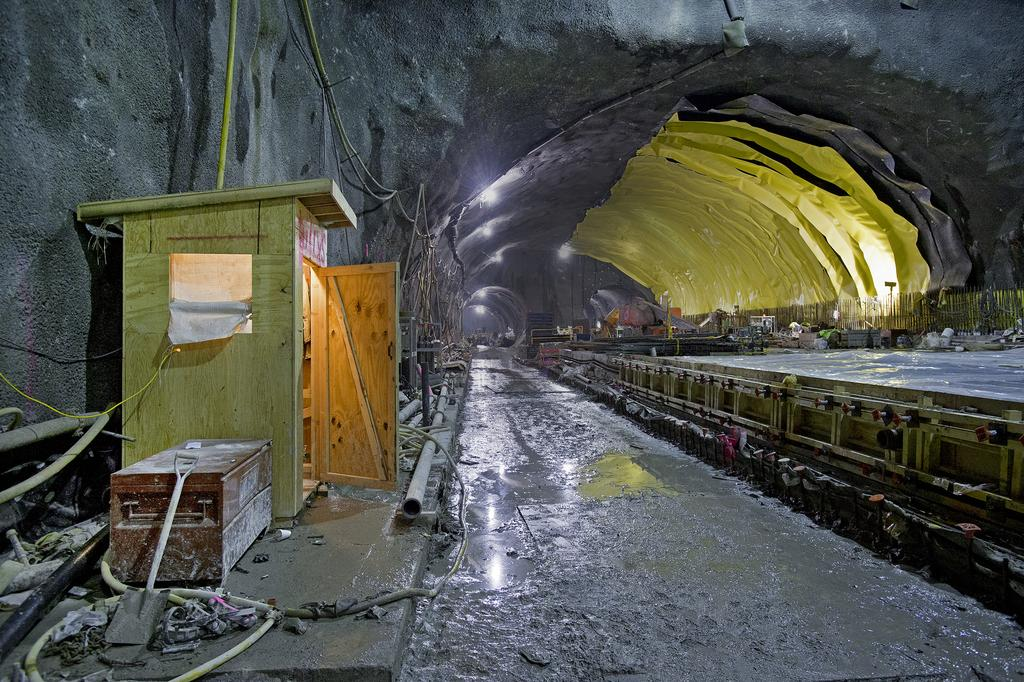What is the main feature of the image? There is a tunnel in the image. What objects can be seen inside the tunnel? A shovel, pipes, a box, cables, and lights are visible in the tunnel. Are there any people present in the image? Yes, there are people in the image. What type of mist can be seen surrounding the people in the image? There is no mist present in the image; it is a clear tunnel with visible objects and people. 